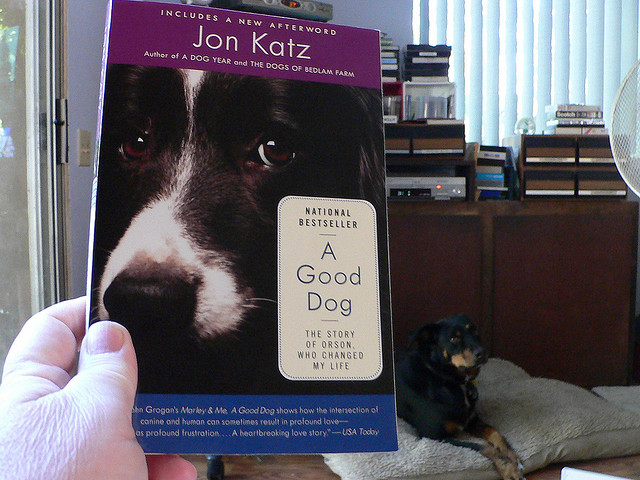Extract all visible text content from this image. Dog BESTSELLER NATIONAL WHO story love heart breaking A profound as Today USA LOVE profound in result sometimes can human and CONINE at intersection the how shows Dog Good A Me Grogan's MY LIFE CHANGED OF ORSON STORY THE A FARM OF DOGS THE and YEAR DOG A of Author Jon Katz AFTERWORD NEW A INCLUDES 